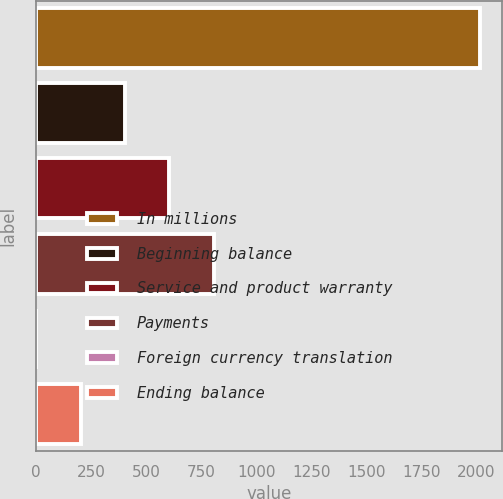Convert chart. <chart><loc_0><loc_0><loc_500><loc_500><bar_chart><fcel>In millions<fcel>Beginning balance<fcel>Service and product warranty<fcel>Payments<fcel>Foreign currency translation<fcel>Ending balance<nl><fcel>2015<fcel>403.8<fcel>605.2<fcel>806.6<fcel>1<fcel>202.4<nl></chart> 